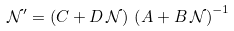Convert formula to latex. <formula><loc_0><loc_0><loc_500><loc_500>\mathcal { N } ^ { \prime } = \left ( C + D \, \mathcal { N } \right ) \, \left ( A + B \, \mathcal { N } \right ) ^ { - 1 }</formula> 